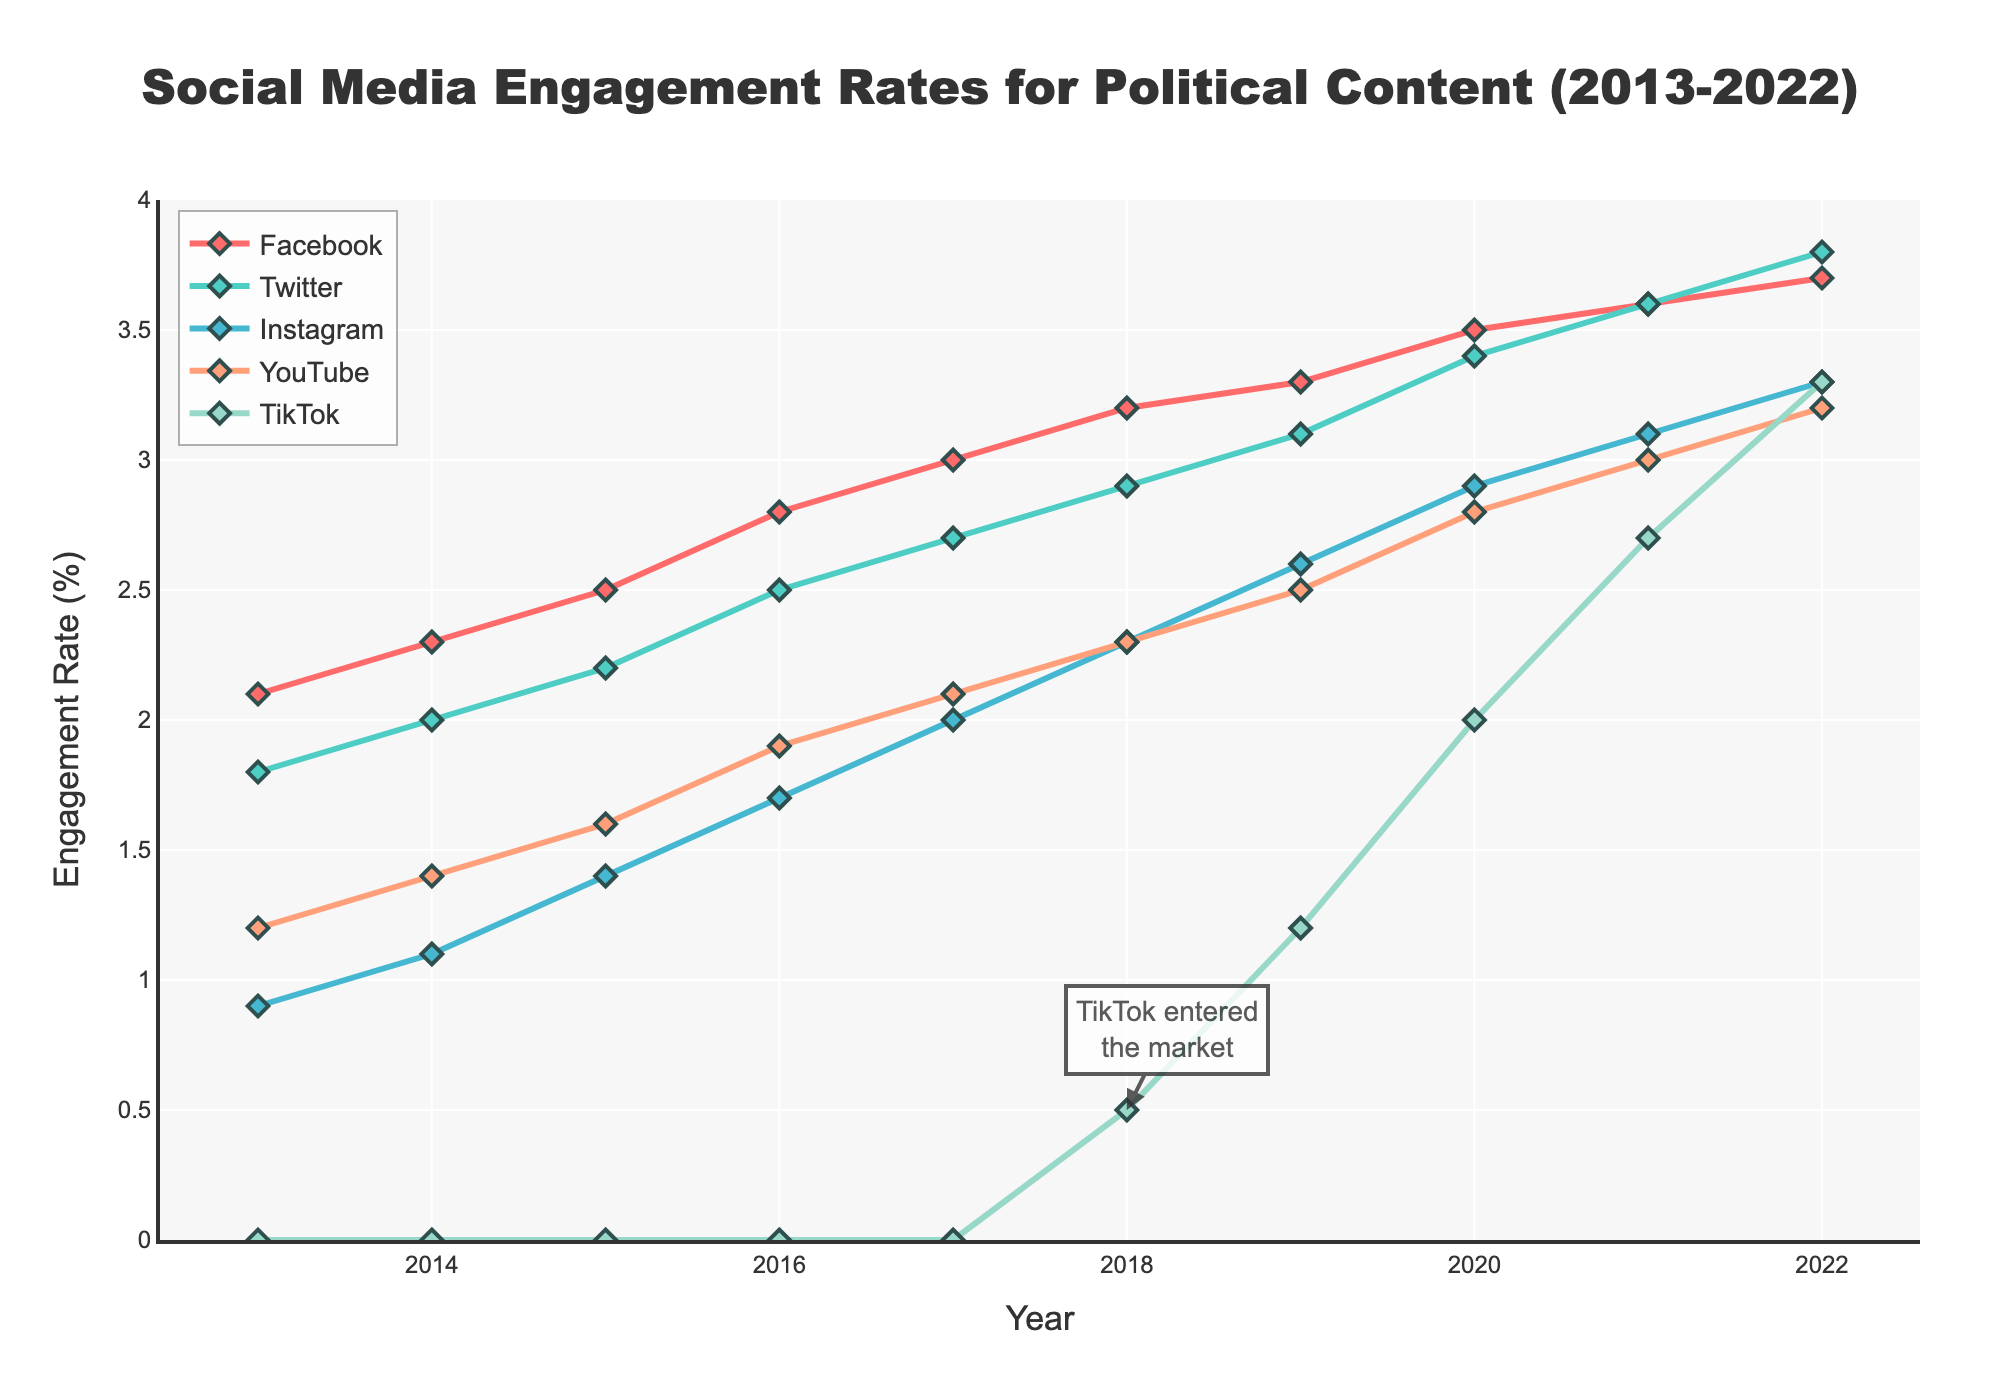Which platform had the highest engagement rate in 2022? By examining the figure, look at the endpoint of each line in 2022. The highest value is for TikTok.
Answer: TikTok How did the engagement rate for YouTube change from 2013 to 2022? Look at the values for YouTube in 2013 and 2022 and calculate the difference. YouTube started at 1.2% in 2013 and went up to 3.2% in 2022, hence the change is 3.2% - 1.2% = 2%.
Answer: Increased by 2% Which year observed the most significant increase in TikTok engagement rate? Refer to the TikTok line on the chart, notice between 2019 and 2020 the rise from 1.2% to 2.0% is the largest individual year increase.
Answer: 2020 Compare the engagement rate changes between Facebook and Instagram from 2015 to 2018. Identify the 2015 and 2018 values for both platforms. For Facebook: 2.5% to 3.2%, change of 0.7%. For Instagram: 1.4% to 2.3%, change of 0.9%.
Answer: Facebook +0.7%, Instagram +0.9% Which platform had the lowest engagement rate in 2016 and what was it? Observe the values for all platforms in 2016 and identify the lowest one. Instagram had the lowest engagement rate at 1.7%.
Answer: Instagram, 1.7% When did TikTok first appear in the chart and what was its initial engagement rate? The annotation and the plot indicate that TikTok first appeared in 2018 with an initial engagement rate of 0.5%.
Answer: 2018, 0.5% Calculate the average engagement rate for Twitter over the decade. Sum up the yearly engagement rates for Twitter and divide by the number of years (10): (1.8+2.0+2.2+2.5+2.7+2.9+3.1+3.4+3.6+3.8) / 10 = 2.8%
Answer: 2.8% What is the difference in engagement rate between Facebook and Twitter in 2021? Find the engagement rates for Facebook and Twitter in 2021. Facebook is 3.6%, and Twitter is 3.6%. The difference is 0%.
Answer: 0% Rank the platforms based on their engagement rates in 2019 from highest to lowest. Check the engagement rates for all platforms for 2019: Facebook (3.3%), Twitter (3.1%), Instagram (2.6%), YouTube (2.5%), TikTok (1.2%).
Answer: Facebook > Twitter > Instagram > YouTube > TikTok Between which years did YouTube's engagement rate remain constant? Look at the years with the same YouTube engagement rates. It remains constant between 2017 and 2018 at 2.3%.
Answer: 2017-2018 